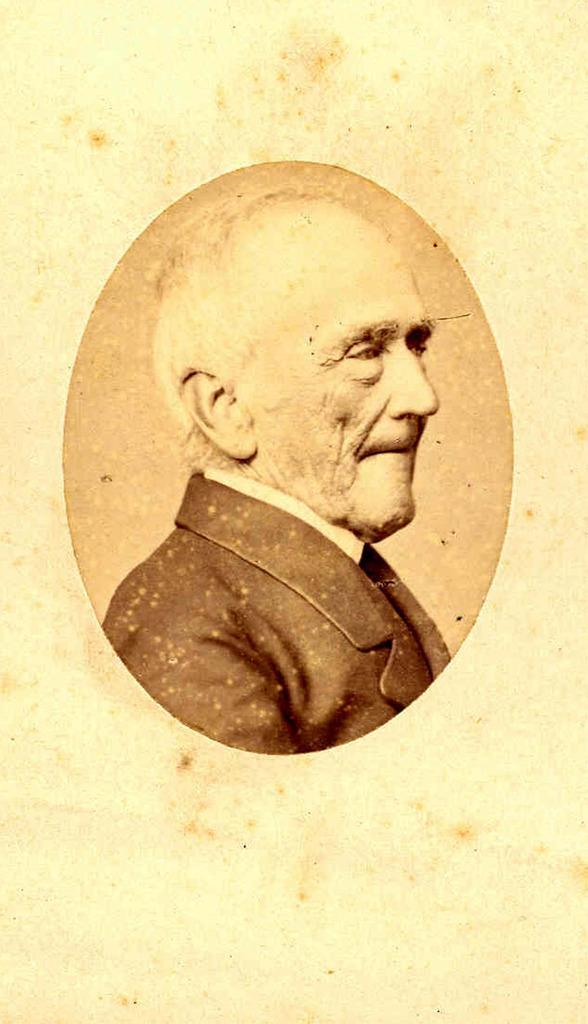In one or two sentences, can you explain what this image depicts? In this image there is one picture of a person in middle of this image. 